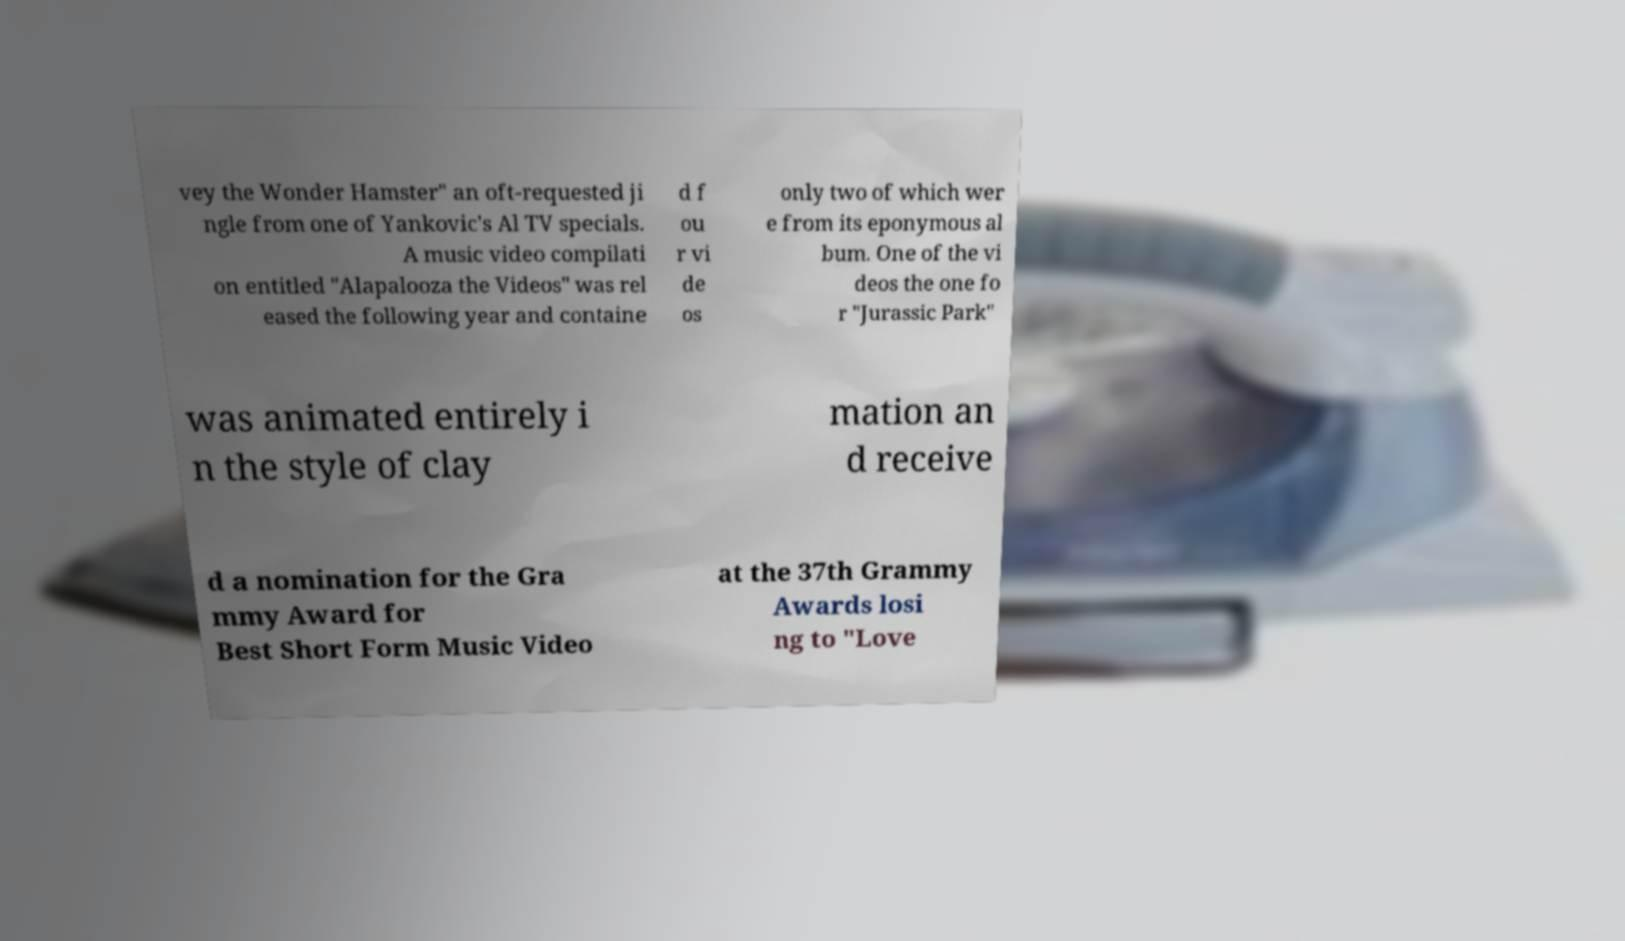There's text embedded in this image that I need extracted. Can you transcribe it verbatim? vey the Wonder Hamster" an oft-requested ji ngle from one of Yankovic's Al TV specials. A music video compilati on entitled "Alapalooza the Videos" was rel eased the following year and containe d f ou r vi de os only two of which wer e from its eponymous al bum. One of the vi deos the one fo r "Jurassic Park" was animated entirely i n the style of clay mation an d receive d a nomination for the Gra mmy Award for Best Short Form Music Video at the 37th Grammy Awards losi ng to "Love 